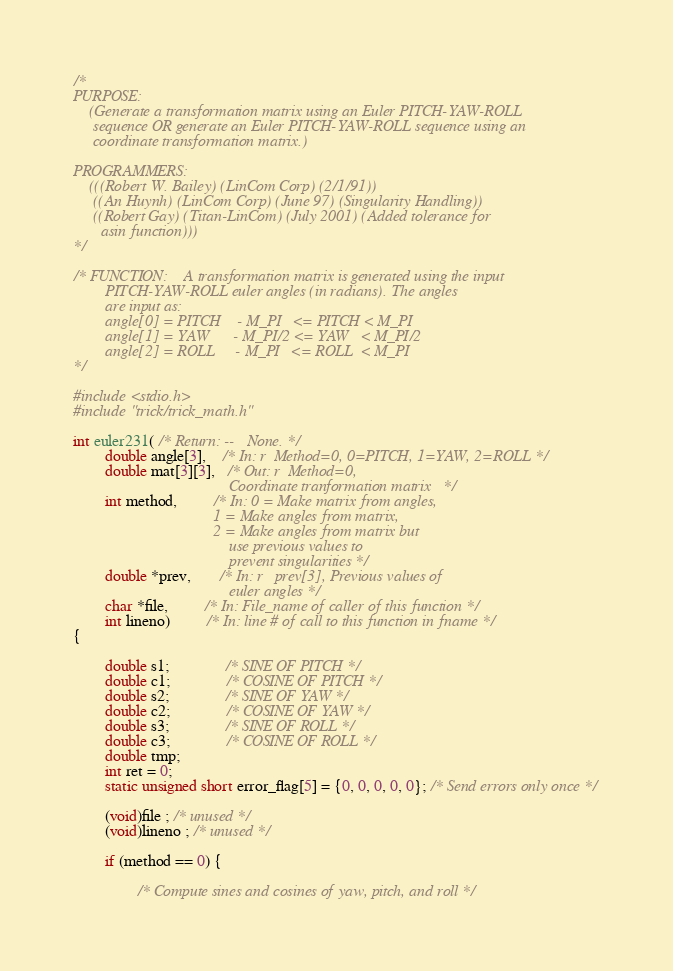Convert code to text. <code><loc_0><loc_0><loc_500><loc_500><_C_>/*
PURPOSE:
    (Generate a transformation matrix using an Euler PITCH-YAW-ROLL
     sequence OR generate an Euler PITCH-YAW-ROLL sequence using an
     coordinate transformation matrix.)

PROGRAMMERS:
    (((Robert W. Bailey) (LinCom Corp) (2/1/91))
     ((An Huynh) (LinCom Corp) (June 97) (Singularity Handling))
     ((Robert Gay) (Titan-LinCom) (July 2001) (Added tolerance for
       asin function)))
*/

/* FUNCTION:    A transformation matrix is generated using the input
        PITCH-YAW-ROLL euler angles (in radians). The angles
        are input as:
        angle[0] = PITCH    - M_PI   <= PITCH < M_PI
        angle[1] = YAW      - M_PI/2 <= YAW   < M_PI/2
        angle[2] = ROLL     - M_PI   <= ROLL  < M_PI
*/

#include <stdio.h>
#include "trick/trick_math.h"

int euler231( /* Return: --   None. */
        double angle[3],    /* In: r  Method=0, 0=PITCH, 1=YAW, 2=ROLL */
        double mat[3][3],   /* Out: r  Method=0, 
                                       Coordinate tranformation matrix   */
        int method,         /* In: 0 = Make matrix from angles,
                                   1 = Make angles from matrix,
                                   2 = Make angles from matrix but 
                                       use previous values to 
                                       prevent singularities */
        double *prev,       /* In: r   prev[3], Previous values of 
                                       euler angles */
        char *file,         /* In: File_name of caller of this function */
        int lineno)         /* In: line # of call to this function in fname */
{

        double s1;              /* SINE OF PITCH */
        double c1;              /* COSINE OF PITCH */
        double s2;              /* SINE OF YAW */
        double c2;              /* COSINE OF YAW */
        double s3;              /* SINE OF ROLL */
        double c3;              /* COSINE OF ROLL */
        double tmp;
        int ret = 0;
        static unsigned short error_flag[5] = {0, 0, 0, 0, 0}; /* Send errors only once */

        (void)file ; /* unused */
        (void)lineno ; /* unused */

        if (method == 0) {

                /* Compute sines and cosines of yaw, pitch, and roll */</code> 